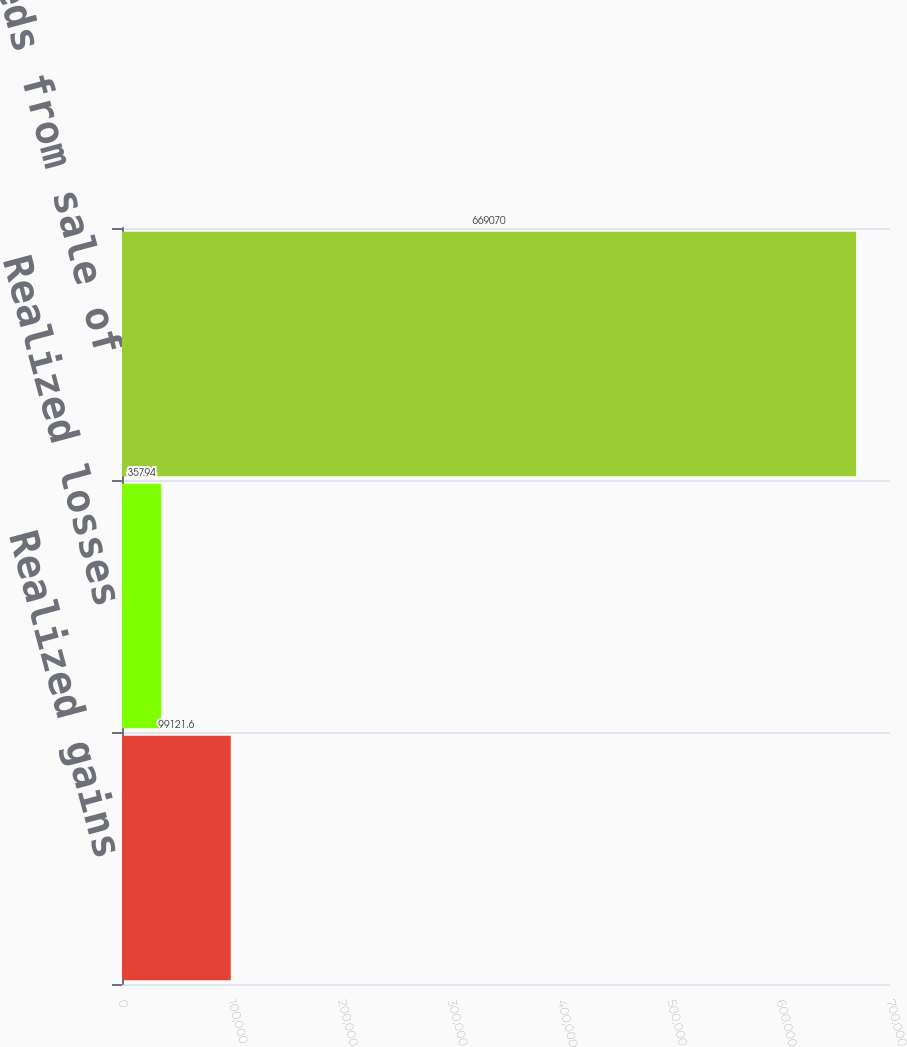Convert chart to OTSL. <chart><loc_0><loc_0><loc_500><loc_500><bar_chart><fcel>Realized gains<fcel>Realized losses<fcel>Proceeds from sale of<nl><fcel>99121.6<fcel>35794<fcel>669070<nl></chart> 